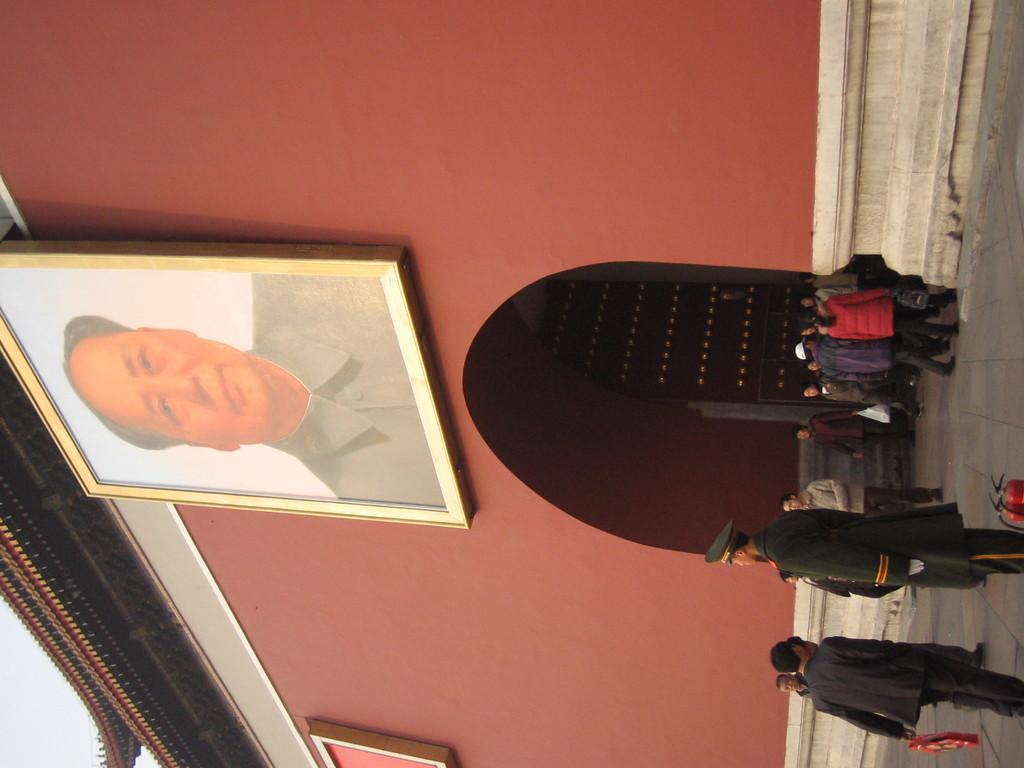Describe this image in one or two sentences. In the image there is a building and there is a big photo frame in front of the wall of the building, under the photo frame there is a door and in front of the door there are few people. 